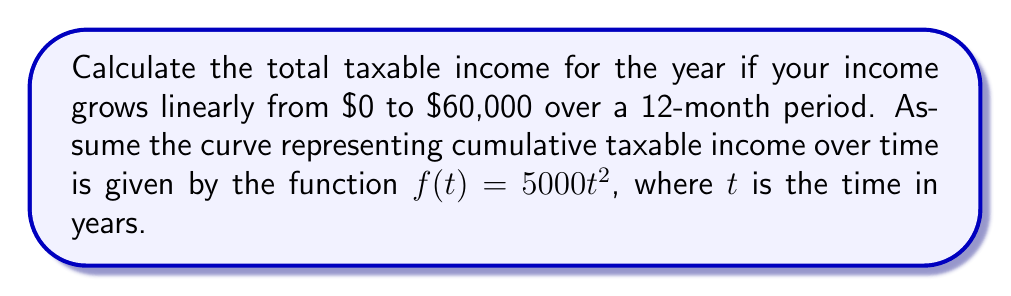Teach me how to tackle this problem. To find the total taxable income, we need to calculate the area under the curve $f(t) = 5000t^2$ from $t=0$ to $t=1$ (representing one year).

1. We can use the definite integral to find the area under the curve:

   $$\text{Total Income} = \int_0^1 f(t) dt = \int_0^1 5000t^2 dt$$

2. Integrate the function:
   
   $$\int_0^1 5000t^2 dt = 5000 \int_0^1 t^2 dt = 5000 \cdot [\frac{1}{3}t^3]_0^1$$

3. Evaluate the integral:

   $$5000 \cdot [\frac{1}{3}t^3]_0^1 = 5000 \cdot (\frac{1}{3} \cdot 1^3 - \frac{1}{3} \cdot 0^3) = 5000 \cdot \frac{1}{3} = \frac{5000}{3}$$

4. Simplify the result:

   $$\frac{5000}{3} \approx 1666.67$$

Therefore, the total taxable income for the year is approximately $1,666.67.
Answer: $1,666.67 